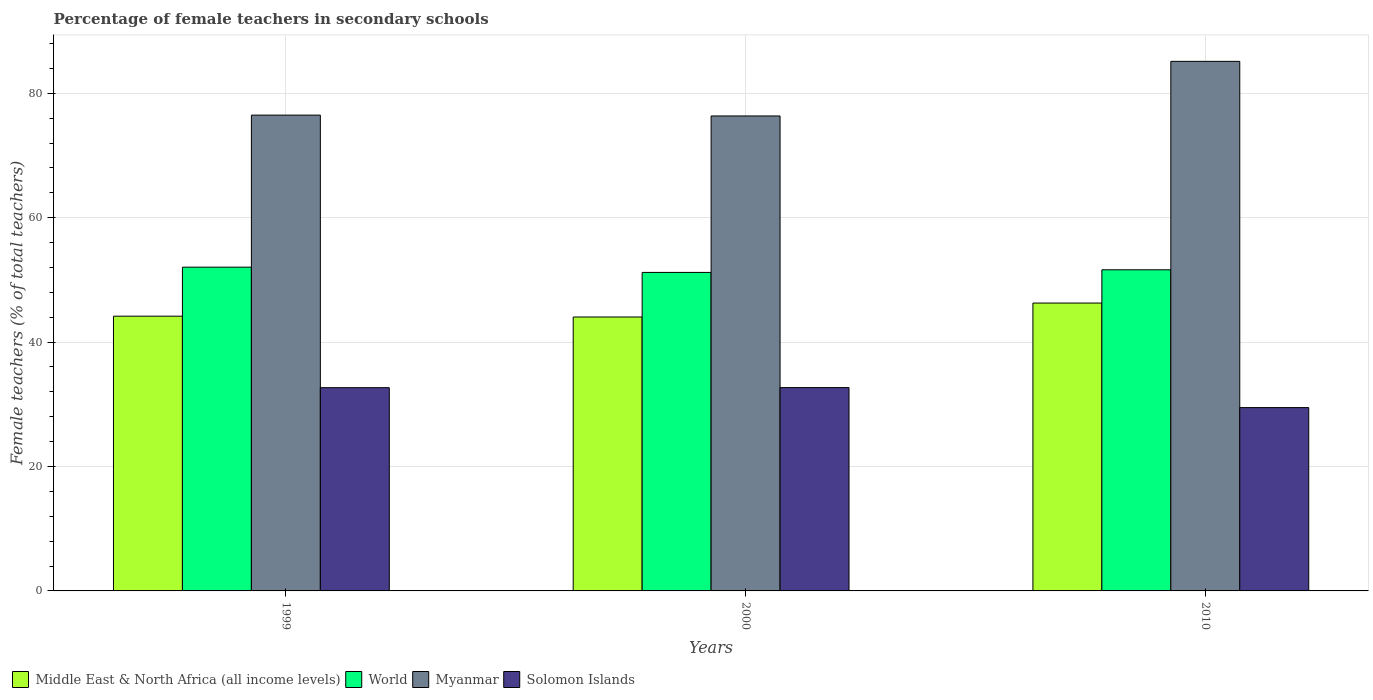How many different coloured bars are there?
Provide a succinct answer. 4. How many groups of bars are there?
Provide a short and direct response. 3. Are the number of bars per tick equal to the number of legend labels?
Ensure brevity in your answer.  Yes. How many bars are there on the 1st tick from the left?
Provide a succinct answer. 4. How many bars are there on the 2nd tick from the right?
Give a very brief answer. 4. What is the percentage of female teachers in Myanmar in 1999?
Make the answer very short. 76.49. Across all years, what is the maximum percentage of female teachers in World?
Keep it short and to the point. 52.05. Across all years, what is the minimum percentage of female teachers in Solomon Islands?
Your answer should be compact. 29.47. In which year was the percentage of female teachers in World maximum?
Your response must be concise. 1999. In which year was the percentage of female teachers in World minimum?
Your response must be concise. 2000. What is the total percentage of female teachers in World in the graph?
Provide a succinct answer. 154.87. What is the difference between the percentage of female teachers in Solomon Islands in 2000 and that in 2010?
Your answer should be very brief. 3.22. What is the difference between the percentage of female teachers in Solomon Islands in 2010 and the percentage of female teachers in World in 1999?
Ensure brevity in your answer.  -22.58. What is the average percentage of female teachers in Solomon Islands per year?
Give a very brief answer. 31.61. In the year 2010, what is the difference between the percentage of female teachers in Middle East & North Africa (all income levels) and percentage of female teachers in Solomon Islands?
Offer a terse response. 16.81. What is the ratio of the percentage of female teachers in World in 2000 to that in 2010?
Make the answer very short. 0.99. What is the difference between the highest and the second highest percentage of female teachers in Myanmar?
Your answer should be very brief. 8.64. What is the difference between the highest and the lowest percentage of female teachers in Solomon Islands?
Your response must be concise. 3.22. What does the 2nd bar from the left in 2010 represents?
Ensure brevity in your answer.  World. What does the 1st bar from the right in 2010 represents?
Keep it short and to the point. Solomon Islands. Is it the case that in every year, the sum of the percentage of female teachers in Solomon Islands and percentage of female teachers in Myanmar is greater than the percentage of female teachers in World?
Keep it short and to the point. Yes. Are the values on the major ticks of Y-axis written in scientific E-notation?
Your answer should be very brief. No. Does the graph contain any zero values?
Give a very brief answer. No. Does the graph contain grids?
Your response must be concise. Yes. Where does the legend appear in the graph?
Your answer should be compact. Bottom left. How many legend labels are there?
Offer a terse response. 4. How are the legend labels stacked?
Give a very brief answer. Horizontal. What is the title of the graph?
Provide a succinct answer. Percentage of female teachers in secondary schools. What is the label or title of the Y-axis?
Your answer should be very brief. Female teachers (% of total teachers). What is the Female teachers (% of total teachers) of Middle East & North Africa (all income levels) in 1999?
Your answer should be compact. 44.17. What is the Female teachers (% of total teachers) in World in 1999?
Offer a very short reply. 52.05. What is the Female teachers (% of total teachers) of Myanmar in 1999?
Provide a succinct answer. 76.49. What is the Female teachers (% of total teachers) in Solomon Islands in 1999?
Your answer should be very brief. 32.67. What is the Female teachers (% of total teachers) in Middle East & North Africa (all income levels) in 2000?
Give a very brief answer. 44.03. What is the Female teachers (% of total teachers) in World in 2000?
Keep it short and to the point. 51.2. What is the Female teachers (% of total teachers) of Myanmar in 2000?
Provide a short and direct response. 76.35. What is the Female teachers (% of total teachers) of Solomon Islands in 2000?
Your answer should be compact. 32.69. What is the Female teachers (% of total teachers) in Middle East & North Africa (all income levels) in 2010?
Ensure brevity in your answer.  46.28. What is the Female teachers (% of total teachers) in World in 2010?
Offer a terse response. 51.62. What is the Female teachers (% of total teachers) in Myanmar in 2010?
Keep it short and to the point. 85.13. What is the Female teachers (% of total teachers) in Solomon Islands in 2010?
Provide a short and direct response. 29.47. Across all years, what is the maximum Female teachers (% of total teachers) of Middle East & North Africa (all income levels)?
Ensure brevity in your answer.  46.28. Across all years, what is the maximum Female teachers (% of total teachers) in World?
Provide a short and direct response. 52.05. Across all years, what is the maximum Female teachers (% of total teachers) of Myanmar?
Offer a very short reply. 85.13. Across all years, what is the maximum Female teachers (% of total teachers) in Solomon Islands?
Give a very brief answer. 32.69. Across all years, what is the minimum Female teachers (% of total teachers) in Middle East & North Africa (all income levels)?
Offer a terse response. 44.03. Across all years, what is the minimum Female teachers (% of total teachers) of World?
Keep it short and to the point. 51.2. Across all years, what is the minimum Female teachers (% of total teachers) in Myanmar?
Your answer should be compact. 76.35. Across all years, what is the minimum Female teachers (% of total teachers) of Solomon Islands?
Provide a short and direct response. 29.47. What is the total Female teachers (% of total teachers) in Middle East & North Africa (all income levels) in the graph?
Ensure brevity in your answer.  134.48. What is the total Female teachers (% of total teachers) in World in the graph?
Your answer should be compact. 154.87. What is the total Female teachers (% of total teachers) of Myanmar in the graph?
Your answer should be very brief. 237.98. What is the total Female teachers (% of total teachers) in Solomon Islands in the graph?
Your answer should be very brief. 94.83. What is the difference between the Female teachers (% of total teachers) of Middle East & North Africa (all income levels) in 1999 and that in 2000?
Give a very brief answer. 0.13. What is the difference between the Female teachers (% of total teachers) of World in 1999 and that in 2000?
Ensure brevity in your answer.  0.84. What is the difference between the Female teachers (% of total teachers) of Myanmar in 1999 and that in 2000?
Ensure brevity in your answer.  0.14. What is the difference between the Female teachers (% of total teachers) of Solomon Islands in 1999 and that in 2000?
Your answer should be compact. -0.01. What is the difference between the Female teachers (% of total teachers) in Middle East & North Africa (all income levels) in 1999 and that in 2010?
Make the answer very short. -2.11. What is the difference between the Female teachers (% of total teachers) in World in 1999 and that in 2010?
Provide a short and direct response. 0.42. What is the difference between the Female teachers (% of total teachers) of Myanmar in 1999 and that in 2010?
Your answer should be compact. -8.64. What is the difference between the Female teachers (% of total teachers) of Solomon Islands in 1999 and that in 2010?
Your answer should be compact. 3.2. What is the difference between the Female teachers (% of total teachers) of Middle East & North Africa (all income levels) in 2000 and that in 2010?
Provide a short and direct response. -2.24. What is the difference between the Female teachers (% of total teachers) of World in 2000 and that in 2010?
Offer a very short reply. -0.42. What is the difference between the Female teachers (% of total teachers) of Myanmar in 2000 and that in 2010?
Your answer should be very brief. -8.78. What is the difference between the Female teachers (% of total teachers) in Solomon Islands in 2000 and that in 2010?
Provide a succinct answer. 3.22. What is the difference between the Female teachers (% of total teachers) in Middle East & North Africa (all income levels) in 1999 and the Female teachers (% of total teachers) in World in 2000?
Your answer should be compact. -7.03. What is the difference between the Female teachers (% of total teachers) in Middle East & North Africa (all income levels) in 1999 and the Female teachers (% of total teachers) in Myanmar in 2000?
Your answer should be very brief. -32.19. What is the difference between the Female teachers (% of total teachers) in Middle East & North Africa (all income levels) in 1999 and the Female teachers (% of total teachers) in Solomon Islands in 2000?
Your response must be concise. 11.48. What is the difference between the Female teachers (% of total teachers) in World in 1999 and the Female teachers (% of total teachers) in Myanmar in 2000?
Ensure brevity in your answer.  -24.31. What is the difference between the Female teachers (% of total teachers) of World in 1999 and the Female teachers (% of total teachers) of Solomon Islands in 2000?
Offer a very short reply. 19.36. What is the difference between the Female teachers (% of total teachers) of Myanmar in 1999 and the Female teachers (% of total teachers) of Solomon Islands in 2000?
Provide a short and direct response. 43.8. What is the difference between the Female teachers (% of total teachers) of Middle East & North Africa (all income levels) in 1999 and the Female teachers (% of total teachers) of World in 2010?
Make the answer very short. -7.46. What is the difference between the Female teachers (% of total teachers) of Middle East & North Africa (all income levels) in 1999 and the Female teachers (% of total teachers) of Myanmar in 2010?
Make the answer very short. -40.96. What is the difference between the Female teachers (% of total teachers) in Middle East & North Africa (all income levels) in 1999 and the Female teachers (% of total teachers) in Solomon Islands in 2010?
Give a very brief answer. 14.7. What is the difference between the Female teachers (% of total teachers) in World in 1999 and the Female teachers (% of total teachers) in Myanmar in 2010?
Ensure brevity in your answer.  -33.09. What is the difference between the Female teachers (% of total teachers) in World in 1999 and the Female teachers (% of total teachers) in Solomon Islands in 2010?
Keep it short and to the point. 22.58. What is the difference between the Female teachers (% of total teachers) in Myanmar in 1999 and the Female teachers (% of total teachers) in Solomon Islands in 2010?
Your answer should be very brief. 47.02. What is the difference between the Female teachers (% of total teachers) of Middle East & North Africa (all income levels) in 2000 and the Female teachers (% of total teachers) of World in 2010?
Offer a very short reply. -7.59. What is the difference between the Female teachers (% of total teachers) of Middle East & North Africa (all income levels) in 2000 and the Female teachers (% of total teachers) of Myanmar in 2010?
Your answer should be very brief. -41.1. What is the difference between the Female teachers (% of total teachers) of Middle East & North Africa (all income levels) in 2000 and the Female teachers (% of total teachers) of Solomon Islands in 2010?
Give a very brief answer. 14.56. What is the difference between the Female teachers (% of total teachers) in World in 2000 and the Female teachers (% of total teachers) in Myanmar in 2010?
Provide a succinct answer. -33.93. What is the difference between the Female teachers (% of total teachers) of World in 2000 and the Female teachers (% of total teachers) of Solomon Islands in 2010?
Keep it short and to the point. 21.73. What is the difference between the Female teachers (% of total teachers) in Myanmar in 2000 and the Female teachers (% of total teachers) in Solomon Islands in 2010?
Make the answer very short. 46.88. What is the average Female teachers (% of total teachers) of Middle East & North Africa (all income levels) per year?
Provide a short and direct response. 44.83. What is the average Female teachers (% of total teachers) in World per year?
Offer a terse response. 51.62. What is the average Female teachers (% of total teachers) in Myanmar per year?
Provide a succinct answer. 79.33. What is the average Female teachers (% of total teachers) of Solomon Islands per year?
Give a very brief answer. 31.61. In the year 1999, what is the difference between the Female teachers (% of total teachers) in Middle East & North Africa (all income levels) and Female teachers (% of total teachers) in World?
Provide a short and direct response. -7.88. In the year 1999, what is the difference between the Female teachers (% of total teachers) of Middle East & North Africa (all income levels) and Female teachers (% of total teachers) of Myanmar?
Make the answer very short. -32.32. In the year 1999, what is the difference between the Female teachers (% of total teachers) in Middle East & North Africa (all income levels) and Female teachers (% of total teachers) in Solomon Islands?
Ensure brevity in your answer.  11.5. In the year 1999, what is the difference between the Female teachers (% of total teachers) of World and Female teachers (% of total teachers) of Myanmar?
Your answer should be very brief. -24.44. In the year 1999, what is the difference between the Female teachers (% of total teachers) in World and Female teachers (% of total teachers) in Solomon Islands?
Offer a terse response. 19.37. In the year 1999, what is the difference between the Female teachers (% of total teachers) of Myanmar and Female teachers (% of total teachers) of Solomon Islands?
Provide a succinct answer. 43.82. In the year 2000, what is the difference between the Female teachers (% of total teachers) in Middle East & North Africa (all income levels) and Female teachers (% of total teachers) in World?
Keep it short and to the point. -7.17. In the year 2000, what is the difference between the Female teachers (% of total teachers) in Middle East & North Africa (all income levels) and Female teachers (% of total teachers) in Myanmar?
Your answer should be very brief. -32.32. In the year 2000, what is the difference between the Female teachers (% of total teachers) of Middle East & North Africa (all income levels) and Female teachers (% of total teachers) of Solomon Islands?
Make the answer very short. 11.35. In the year 2000, what is the difference between the Female teachers (% of total teachers) of World and Female teachers (% of total teachers) of Myanmar?
Ensure brevity in your answer.  -25.15. In the year 2000, what is the difference between the Female teachers (% of total teachers) in World and Female teachers (% of total teachers) in Solomon Islands?
Offer a terse response. 18.52. In the year 2000, what is the difference between the Female teachers (% of total teachers) in Myanmar and Female teachers (% of total teachers) in Solomon Islands?
Make the answer very short. 43.67. In the year 2010, what is the difference between the Female teachers (% of total teachers) in Middle East & North Africa (all income levels) and Female teachers (% of total teachers) in World?
Offer a terse response. -5.35. In the year 2010, what is the difference between the Female teachers (% of total teachers) in Middle East & North Africa (all income levels) and Female teachers (% of total teachers) in Myanmar?
Give a very brief answer. -38.85. In the year 2010, what is the difference between the Female teachers (% of total teachers) of Middle East & North Africa (all income levels) and Female teachers (% of total teachers) of Solomon Islands?
Provide a short and direct response. 16.81. In the year 2010, what is the difference between the Female teachers (% of total teachers) in World and Female teachers (% of total teachers) in Myanmar?
Provide a succinct answer. -33.51. In the year 2010, what is the difference between the Female teachers (% of total teachers) of World and Female teachers (% of total teachers) of Solomon Islands?
Offer a very short reply. 22.15. In the year 2010, what is the difference between the Female teachers (% of total teachers) in Myanmar and Female teachers (% of total teachers) in Solomon Islands?
Provide a succinct answer. 55.66. What is the ratio of the Female teachers (% of total teachers) of World in 1999 to that in 2000?
Ensure brevity in your answer.  1.02. What is the ratio of the Female teachers (% of total teachers) in Solomon Islands in 1999 to that in 2000?
Your answer should be compact. 1. What is the ratio of the Female teachers (% of total teachers) in Middle East & North Africa (all income levels) in 1999 to that in 2010?
Make the answer very short. 0.95. What is the ratio of the Female teachers (% of total teachers) of World in 1999 to that in 2010?
Offer a very short reply. 1.01. What is the ratio of the Female teachers (% of total teachers) in Myanmar in 1999 to that in 2010?
Offer a very short reply. 0.9. What is the ratio of the Female teachers (% of total teachers) in Solomon Islands in 1999 to that in 2010?
Ensure brevity in your answer.  1.11. What is the ratio of the Female teachers (% of total teachers) in Middle East & North Africa (all income levels) in 2000 to that in 2010?
Give a very brief answer. 0.95. What is the ratio of the Female teachers (% of total teachers) of World in 2000 to that in 2010?
Your answer should be very brief. 0.99. What is the ratio of the Female teachers (% of total teachers) in Myanmar in 2000 to that in 2010?
Offer a very short reply. 0.9. What is the ratio of the Female teachers (% of total teachers) in Solomon Islands in 2000 to that in 2010?
Your answer should be very brief. 1.11. What is the difference between the highest and the second highest Female teachers (% of total teachers) in Middle East & North Africa (all income levels)?
Your answer should be compact. 2.11. What is the difference between the highest and the second highest Female teachers (% of total teachers) in World?
Offer a very short reply. 0.42. What is the difference between the highest and the second highest Female teachers (% of total teachers) in Myanmar?
Offer a terse response. 8.64. What is the difference between the highest and the second highest Female teachers (% of total teachers) in Solomon Islands?
Keep it short and to the point. 0.01. What is the difference between the highest and the lowest Female teachers (% of total teachers) in Middle East & North Africa (all income levels)?
Ensure brevity in your answer.  2.24. What is the difference between the highest and the lowest Female teachers (% of total teachers) of World?
Your answer should be very brief. 0.84. What is the difference between the highest and the lowest Female teachers (% of total teachers) of Myanmar?
Offer a very short reply. 8.78. What is the difference between the highest and the lowest Female teachers (% of total teachers) in Solomon Islands?
Provide a short and direct response. 3.22. 